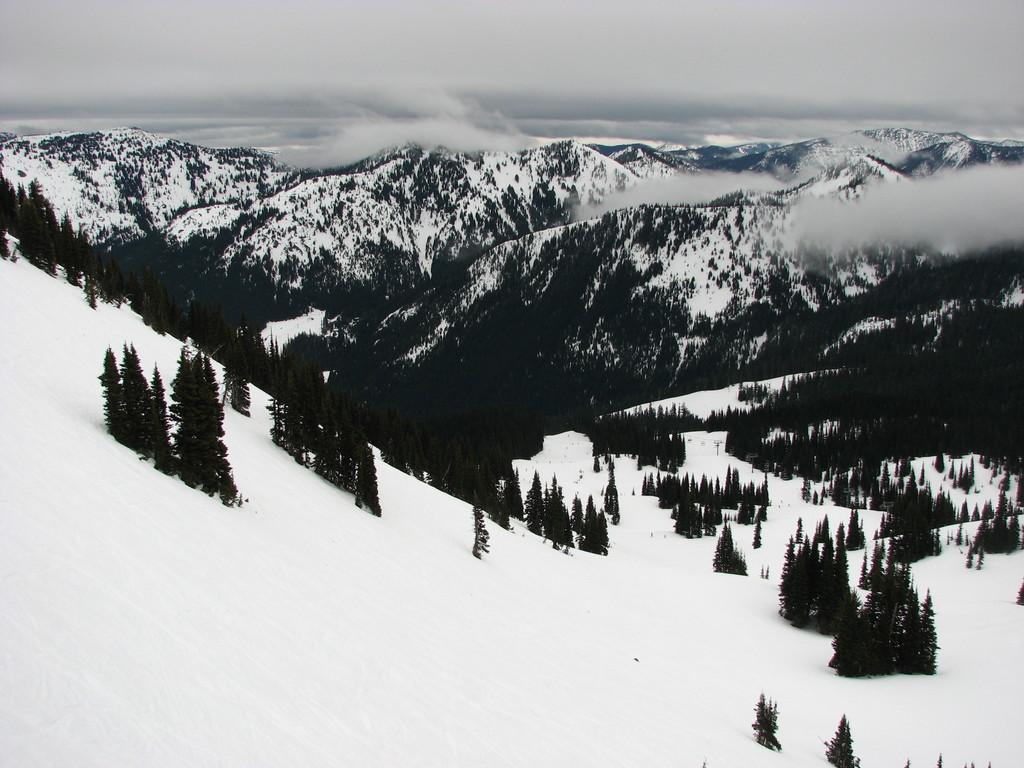Please provide a concise description of this image. In this image I can see the snow. In the back I can see many trees and the mountains. I can also see the fog and the sky in the back. 